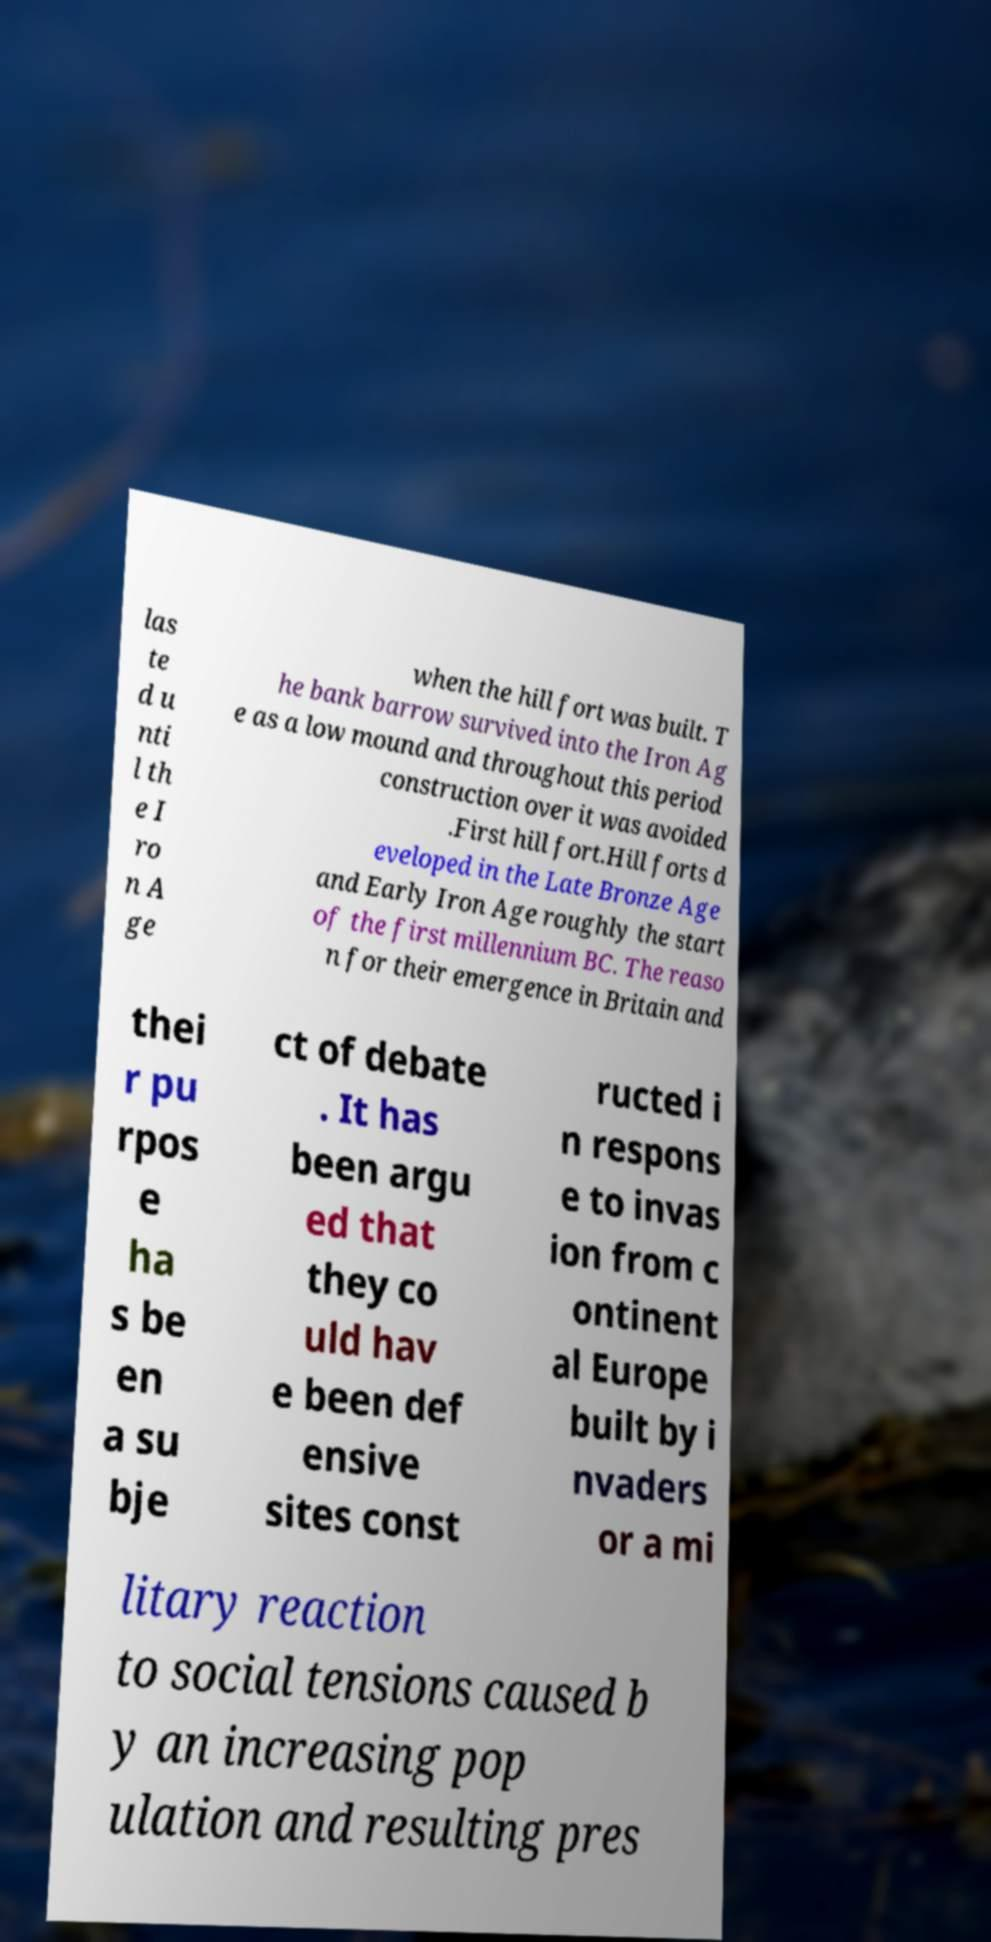Please identify and transcribe the text found in this image. las te d u nti l th e I ro n A ge when the hill fort was built. T he bank barrow survived into the Iron Ag e as a low mound and throughout this period construction over it was avoided .First hill fort.Hill forts d eveloped in the Late Bronze Age and Early Iron Age roughly the start of the first millennium BC. The reaso n for their emergence in Britain and thei r pu rpos e ha s be en a su bje ct of debate . It has been argu ed that they co uld hav e been def ensive sites const ructed i n respons e to invas ion from c ontinent al Europe built by i nvaders or a mi litary reaction to social tensions caused b y an increasing pop ulation and resulting pres 